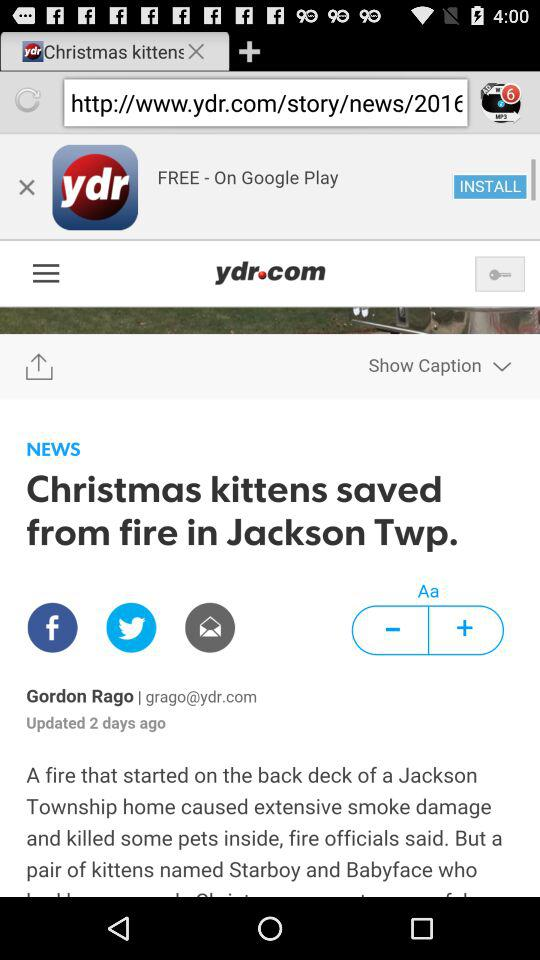Who is the author? The author is Gordon Rago. 